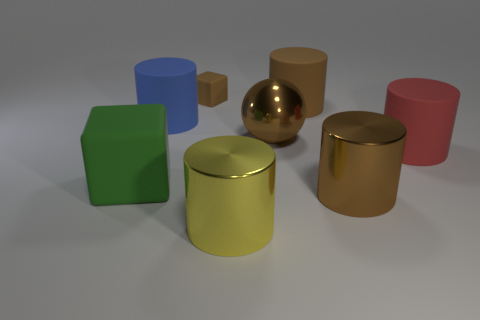Is there a tiny block of the same color as the large metal ball?
Provide a succinct answer. Yes. The metallic thing that is the same color as the metallic ball is what shape?
Offer a terse response. Cylinder. What is the color of the block that is made of the same material as the tiny brown thing?
Offer a very short reply. Green. Is there a cylinder to the right of the brown object that is in front of the brown ball that is to the right of the green rubber object?
Make the answer very short. Yes. What is the shape of the red object?
Offer a very short reply. Cylinder. Are there fewer big red rubber objects that are right of the green matte block than small blocks?
Ensure brevity in your answer.  No. Are there any large green things that have the same shape as the small thing?
Keep it short and to the point. Yes. There is a red object that is the same size as the blue cylinder; what is its shape?
Offer a very short reply. Cylinder. What number of objects are large purple shiny things or brown shiny objects?
Give a very brief answer. 2. Are any purple things visible?
Make the answer very short. No. 